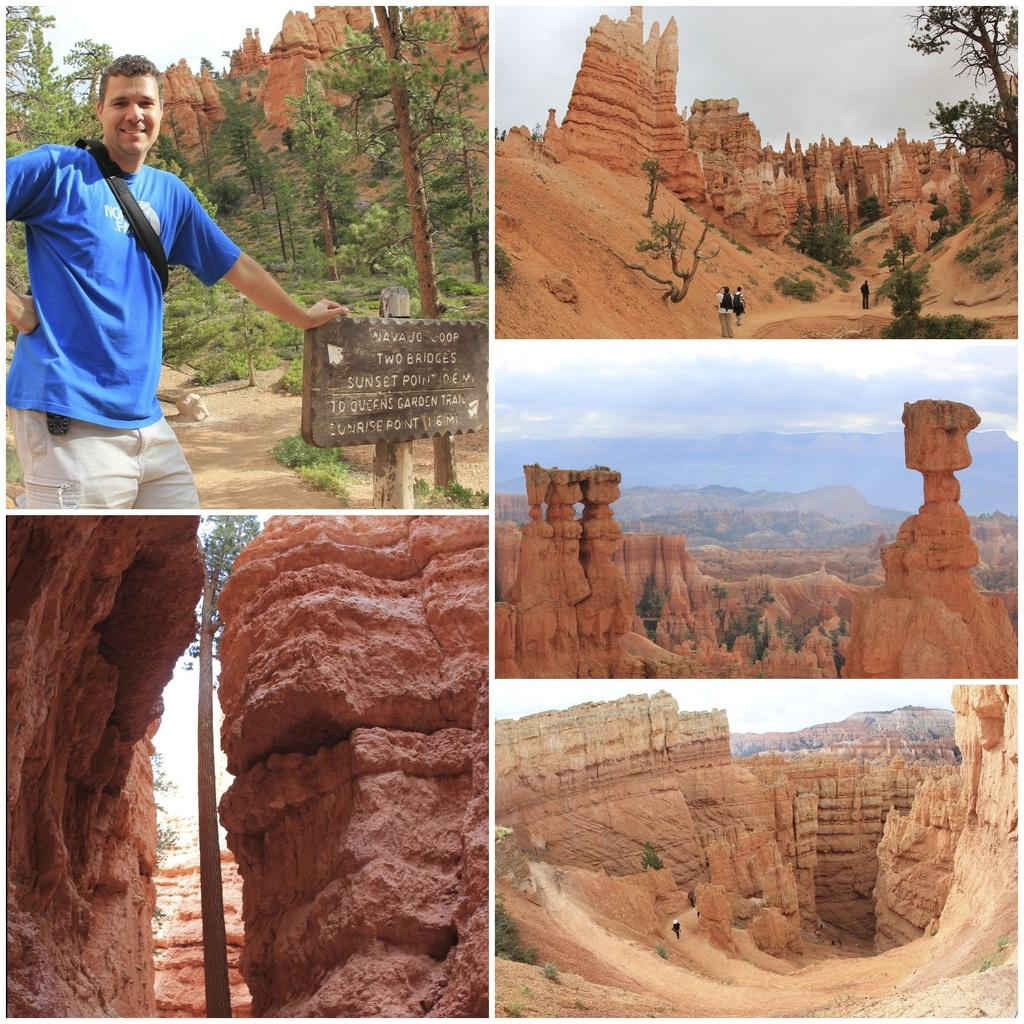What type of structures are visible in the image? There are historical monuments in the image. What natural elements can be seen in the image? There are trees and rocks visible in the image. Who or what is present in the image? There is a group of people and sculptures in the image. What object can be used for displaying information or messages? There is a board in the image. What is visible in the sky in the image? The sky is visible in the image. What type of powder can be seen falling from the sky in the image? There is no powder falling from the sky in the image; the sky is visible but no powder is mentioned in the provided facts. What type of window can be seen in the image? There is no window present in the image; the provided facts mention historical monuments, trees, a group of people, a board, sculptures, rocks, and the sky, but no window. 